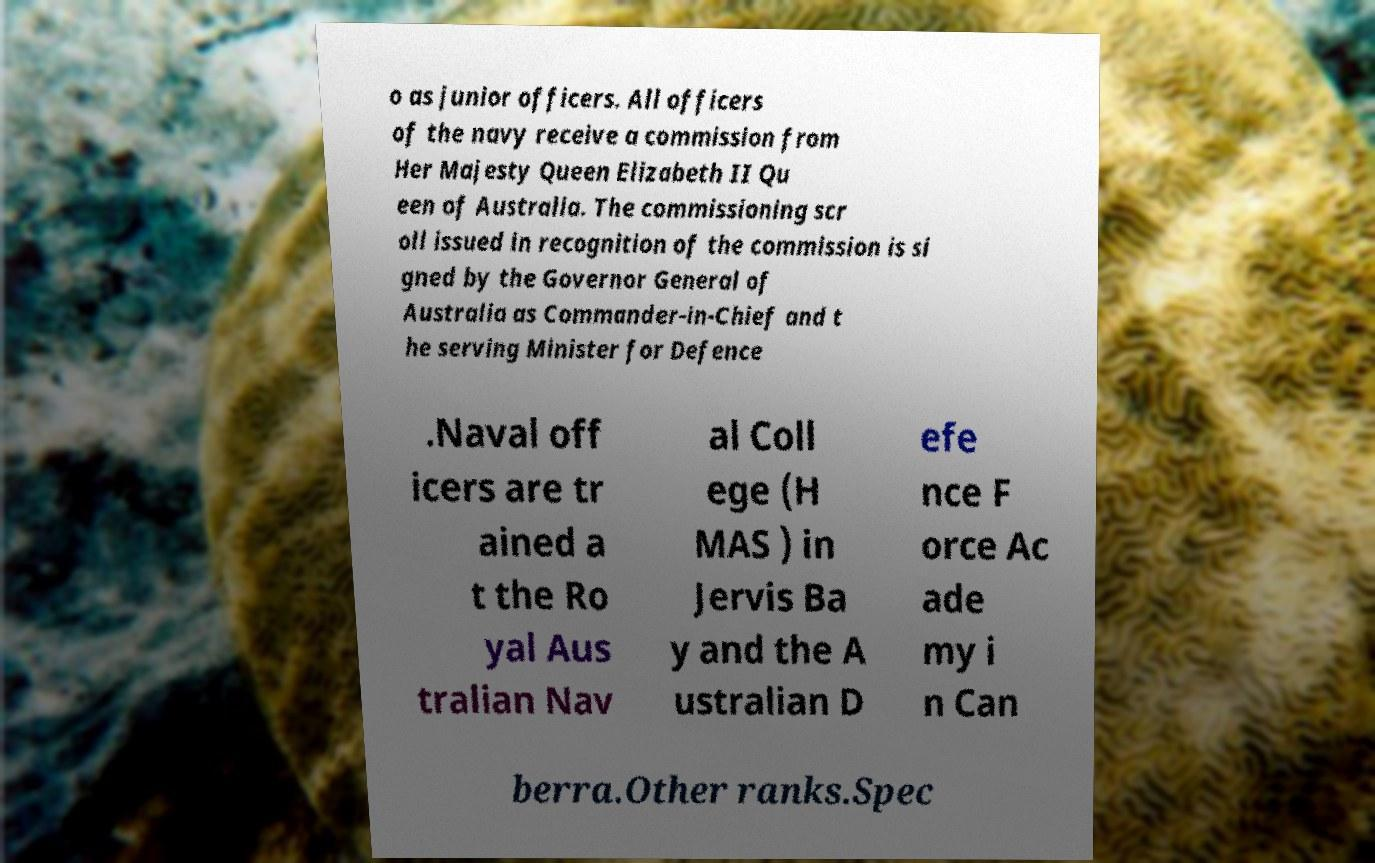Please read and relay the text visible in this image. What does it say? o as junior officers. All officers of the navy receive a commission from Her Majesty Queen Elizabeth II Qu een of Australia. The commissioning scr oll issued in recognition of the commission is si gned by the Governor General of Australia as Commander-in-Chief and t he serving Minister for Defence .Naval off icers are tr ained a t the Ro yal Aus tralian Nav al Coll ege (H MAS ) in Jervis Ba y and the A ustralian D efe nce F orce Ac ade my i n Can berra.Other ranks.Spec 